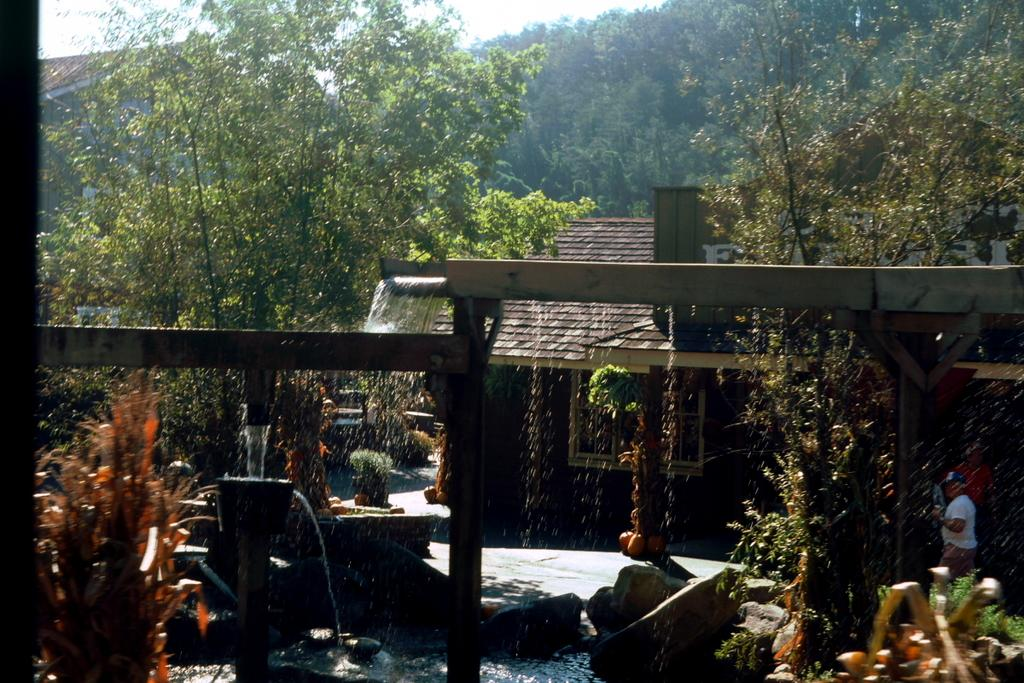What can be seen in the image? There are people standing in the image, and they are wearing clothes. What else is present in the image? There are trees, stones, a house, and the sky is visible. Can you describe the weather in the image? It might be raining, but this is uncertain. How many people are in the image? The number of people is not specified, but there are people present. What nation is being represented by the taste of the stones in the image? There is no mention of taste or a nation in the image, and stones do not have a taste. 